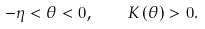<formula> <loc_0><loc_0><loc_500><loc_500>- \eta < \theta < 0 , \quad K \left ( \theta \right ) > 0 .</formula> 